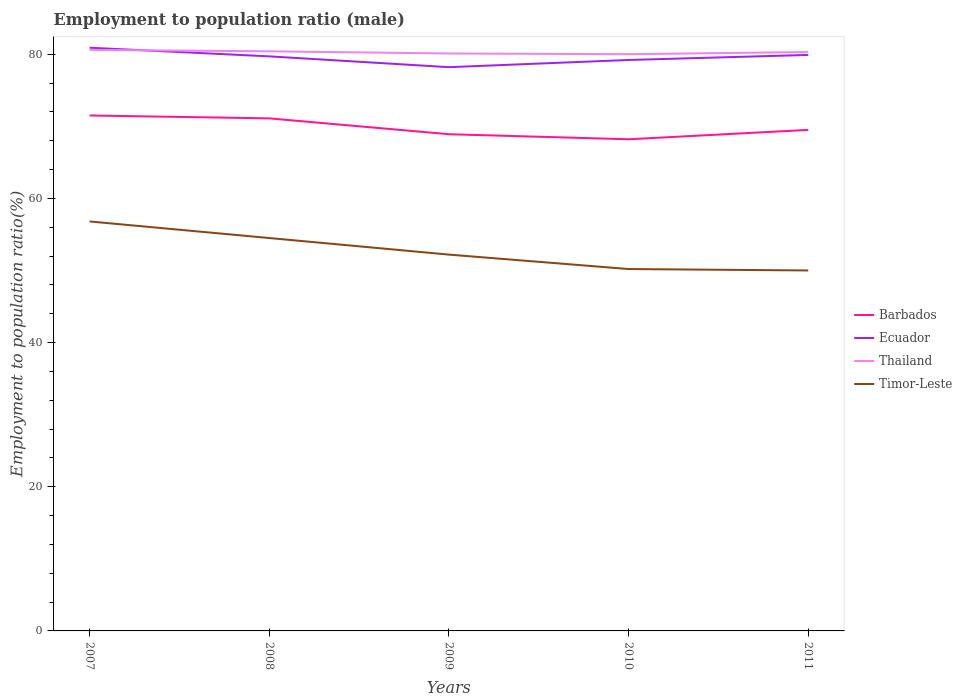Is the number of lines equal to the number of legend labels?
Offer a terse response. Yes. Across all years, what is the maximum employment to population ratio in Timor-Leste?
Keep it short and to the point. 50. In which year was the employment to population ratio in Thailand maximum?
Keep it short and to the point. 2010. What is the difference between the highest and the second highest employment to population ratio in Ecuador?
Ensure brevity in your answer.  2.7. Is the employment to population ratio in Barbados strictly greater than the employment to population ratio in Thailand over the years?
Ensure brevity in your answer.  Yes. How many lines are there?
Your answer should be compact. 4. How many years are there in the graph?
Your answer should be compact. 5. What is the difference between two consecutive major ticks on the Y-axis?
Offer a very short reply. 20. Does the graph contain any zero values?
Your response must be concise. No. How many legend labels are there?
Offer a terse response. 4. How are the legend labels stacked?
Your response must be concise. Vertical. What is the title of the graph?
Your answer should be very brief. Employment to population ratio (male). Does "Bulgaria" appear as one of the legend labels in the graph?
Ensure brevity in your answer.  No. What is the label or title of the X-axis?
Give a very brief answer. Years. What is the Employment to population ratio(%) in Barbados in 2007?
Offer a terse response. 71.5. What is the Employment to population ratio(%) of Ecuador in 2007?
Offer a very short reply. 80.9. What is the Employment to population ratio(%) of Thailand in 2007?
Ensure brevity in your answer.  80.6. What is the Employment to population ratio(%) in Timor-Leste in 2007?
Ensure brevity in your answer.  56.8. What is the Employment to population ratio(%) of Barbados in 2008?
Keep it short and to the point. 71.1. What is the Employment to population ratio(%) of Ecuador in 2008?
Your response must be concise. 79.7. What is the Employment to population ratio(%) in Thailand in 2008?
Provide a short and direct response. 80.4. What is the Employment to population ratio(%) of Timor-Leste in 2008?
Your answer should be compact. 54.5. What is the Employment to population ratio(%) in Barbados in 2009?
Provide a short and direct response. 68.9. What is the Employment to population ratio(%) in Ecuador in 2009?
Make the answer very short. 78.2. What is the Employment to population ratio(%) in Thailand in 2009?
Your response must be concise. 80.1. What is the Employment to population ratio(%) in Timor-Leste in 2009?
Keep it short and to the point. 52.2. What is the Employment to population ratio(%) in Barbados in 2010?
Offer a very short reply. 68.2. What is the Employment to population ratio(%) of Ecuador in 2010?
Offer a terse response. 79.2. What is the Employment to population ratio(%) of Thailand in 2010?
Your answer should be compact. 80. What is the Employment to population ratio(%) in Timor-Leste in 2010?
Offer a very short reply. 50.2. What is the Employment to population ratio(%) of Barbados in 2011?
Provide a succinct answer. 69.5. What is the Employment to population ratio(%) of Ecuador in 2011?
Keep it short and to the point. 79.9. What is the Employment to population ratio(%) of Thailand in 2011?
Make the answer very short. 80.3. What is the Employment to population ratio(%) in Timor-Leste in 2011?
Give a very brief answer. 50. Across all years, what is the maximum Employment to population ratio(%) in Barbados?
Give a very brief answer. 71.5. Across all years, what is the maximum Employment to population ratio(%) in Ecuador?
Provide a succinct answer. 80.9. Across all years, what is the maximum Employment to population ratio(%) of Thailand?
Your answer should be compact. 80.6. Across all years, what is the maximum Employment to population ratio(%) of Timor-Leste?
Offer a terse response. 56.8. Across all years, what is the minimum Employment to population ratio(%) in Barbados?
Make the answer very short. 68.2. Across all years, what is the minimum Employment to population ratio(%) of Ecuador?
Ensure brevity in your answer.  78.2. Across all years, what is the minimum Employment to population ratio(%) of Timor-Leste?
Ensure brevity in your answer.  50. What is the total Employment to population ratio(%) in Barbados in the graph?
Your answer should be very brief. 349.2. What is the total Employment to population ratio(%) of Ecuador in the graph?
Your answer should be compact. 397.9. What is the total Employment to population ratio(%) of Thailand in the graph?
Your answer should be compact. 401.4. What is the total Employment to population ratio(%) in Timor-Leste in the graph?
Give a very brief answer. 263.7. What is the difference between the Employment to population ratio(%) of Barbados in 2007 and that in 2008?
Your answer should be compact. 0.4. What is the difference between the Employment to population ratio(%) in Ecuador in 2007 and that in 2008?
Make the answer very short. 1.2. What is the difference between the Employment to population ratio(%) of Barbados in 2007 and that in 2009?
Give a very brief answer. 2.6. What is the difference between the Employment to population ratio(%) of Ecuador in 2007 and that in 2009?
Keep it short and to the point. 2.7. What is the difference between the Employment to population ratio(%) in Timor-Leste in 2007 and that in 2009?
Offer a terse response. 4.6. What is the difference between the Employment to population ratio(%) of Barbados in 2007 and that in 2010?
Offer a terse response. 3.3. What is the difference between the Employment to population ratio(%) in Ecuador in 2007 and that in 2010?
Offer a terse response. 1.7. What is the difference between the Employment to population ratio(%) in Thailand in 2007 and that in 2010?
Make the answer very short. 0.6. What is the difference between the Employment to population ratio(%) of Timor-Leste in 2007 and that in 2010?
Ensure brevity in your answer.  6.6. What is the difference between the Employment to population ratio(%) of Ecuador in 2007 and that in 2011?
Make the answer very short. 1. What is the difference between the Employment to population ratio(%) of Thailand in 2007 and that in 2011?
Your response must be concise. 0.3. What is the difference between the Employment to population ratio(%) in Ecuador in 2008 and that in 2009?
Your answer should be very brief. 1.5. What is the difference between the Employment to population ratio(%) of Timor-Leste in 2008 and that in 2009?
Your response must be concise. 2.3. What is the difference between the Employment to population ratio(%) of Barbados in 2008 and that in 2010?
Ensure brevity in your answer.  2.9. What is the difference between the Employment to population ratio(%) in Ecuador in 2008 and that in 2010?
Offer a terse response. 0.5. What is the difference between the Employment to population ratio(%) of Thailand in 2008 and that in 2010?
Give a very brief answer. 0.4. What is the difference between the Employment to population ratio(%) of Timor-Leste in 2008 and that in 2010?
Your response must be concise. 4.3. What is the difference between the Employment to population ratio(%) of Thailand in 2008 and that in 2011?
Keep it short and to the point. 0.1. What is the difference between the Employment to population ratio(%) in Barbados in 2009 and that in 2010?
Give a very brief answer. 0.7. What is the difference between the Employment to population ratio(%) in Barbados in 2009 and that in 2011?
Your answer should be compact. -0.6. What is the difference between the Employment to population ratio(%) of Ecuador in 2009 and that in 2011?
Ensure brevity in your answer.  -1.7. What is the difference between the Employment to population ratio(%) of Timor-Leste in 2009 and that in 2011?
Provide a succinct answer. 2.2. What is the difference between the Employment to population ratio(%) of Barbados in 2010 and that in 2011?
Your answer should be very brief. -1.3. What is the difference between the Employment to population ratio(%) in Timor-Leste in 2010 and that in 2011?
Your answer should be compact. 0.2. What is the difference between the Employment to population ratio(%) of Barbados in 2007 and the Employment to population ratio(%) of Ecuador in 2008?
Offer a very short reply. -8.2. What is the difference between the Employment to population ratio(%) in Barbados in 2007 and the Employment to population ratio(%) in Thailand in 2008?
Offer a very short reply. -8.9. What is the difference between the Employment to population ratio(%) of Barbados in 2007 and the Employment to population ratio(%) of Timor-Leste in 2008?
Ensure brevity in your answer.  17. What is the difference between the Employment to population ratio(%) in Ecuador in 2007 and the Employment to population ratio(%) in Thailand in 2008?
Provide a short and direct response. 0.5. What is the difference between the Employment to population ratio(%) of Ecuador in 2007 and the Employment to population ratio(%) of Timor-Leste in 2008?
Your answer should be very brief. 26.4. What is the difference between the Employment to population ratio(%) in Thailand in 2007 and the Employment to population ratio(%) in Timor-Leste in 2008?
Keep it short and to the point. 26.1. What is the difference between the Employment to population ratio(%) of Barbados in 2007 and the Employment to population ratio(%) of Ecuador in 2009?
Your answer should be very brief. -6.7. What is the difference between the Employment to population ratio(%) of Barbados in 2007 and the Employment to population ratio(%) of Timor-Leste in 2009?
Give a very brief answer. 19.3. What is the difference between the Employment to population ratio(%) of Ecuador in 2007 and the Employment to population ratio(%) of Thailand in 2009?
Provide a short and direct response. 0.8. What is the difference between the Employment to population ratio(%) in Ecuador in 2007 and the Employment to population ratio(%) in Timor-Leste in 2009?
Your response must be concise. 28.7. What is the difference between the Employment to population ratio(%) of Thailand in 2007 and the Employment to population ratio(%) of Timor-Leste in 2009?
Ensure brevity in your answer.  28.4. What is the difference between the Employment to population ratio(%) of Barbados in 2007 and the Employment to population ratio(%) of Ecuador in 2010?
Ensure brevity in your answer.  -7.7. What is the difference between the Employment to population ratio(%) of Barbados in 2007 and the Employment to population ratio(%) of Thailand in 2010?
Offer a terse response. -8.5. What is the difference between the Employment to population ratio(%) of Barbados in 2007 and the Employment to population ratio(%) of Timor-Leste in 2010?
Keep it short and to the point. 21.3. What is the difference between the Employment to population ratio(%) in Ecuador in 2007 and the Employment to population ratio(%) in Timor-Leste in 2010?
Your answer should be compact. 30.7. What is the difference between the Employment to population ratio(%) in Thailand in 2007 and the Employment to population ratio(%) in Timor-Leste in 2010?
Keep it short and to the point. 30.4. What is the difference between the Employment to population ratio(%) in Barbados in 2007 and the Employment to population ratio(%) in Ecuador in 2011?
Your response must be concise. -8.4. What is the difference between the Employment to population ratio(%) in Ecuador in 2007 and the Employment to population ratio(%) in Timor-Leste in 2011?
Ensure brevity in your answer.  30.9. What is the difference between the Employment to population ratio(%) in Thailand in 2007 and the Employment to population ratio(%) in Timor-Leste in 2011?
Ensure brevity in your answer.  30.6. What is the difference between the Employment to population ratio(%) in Barbados in 2008 and the Employment to population ratio(%) in Timor-Leste in 2009?
Your response must be concise. 18.9. What is the difference between the Employment to population ratio(%) in Ecuador in 2008 and the Employment to population ratio(%) in Thailand in 2009?
Make the answer very short. -0.4. What is the difference between the Employment to population ratio(%) in Thailand in 2008 and the Employment to population ratio(%) in Timor-Leste in 2009?
Make the answer very short. 28.2. What is the difference between the Employment to population ratio(%) of Barbados in 2008 and the Employment to population ratio(%) of Ecuador in 2010?
Keep it short and to the point. -8.1. What is the difference between the Employment to population ratio(%) of Barbados in 2008 and the Employment to population ratio(%) of Timor-Leste in 2010?
Make the answer very short. 20.9. What is the difference between the Employment to population ratio(%) of Ecuador in 2008 and the Employment to population ratio(%) of Timor-Leste in 2010?
Ensure brevity in your answer.  29.5. What is the difference between the Employment to population ratio(%) in Thailand in 2008 and the Employment to population ratio(%) in Timor-Leste in 2010?
Offer a very short reply. 30.2. What is the difference between the Employment to population ratio(%) of Barbados in 2008 and the Employment to population ratio(%) of Timor-Leste in 2011?
Give a very brief answer. 21.1. What is the difference between the Employment to population ratio(%) of Ecuador in 2008 and the Employment to population ratio(%) of Thailand in 2011?
Provide a short and direct response. -0.6. What is the difference between the Employment to population ratio(%) of Ecuador in 2008 and the Employment to population ratio(%) of Timor-Leste in 2011?
Your response must be concise. 29.7. What is the difference between the Employment to population ratio(%) in Thailand in 2008 and the Employment to population ratio(%) in Timor-Leste in 2011?
Offer a terse response. 30.4. What is the difference between the Employment to population ratio(%) of Barbados in 2009 and the Employment to population ratio(%) of Ecuador in 2010?
Your response must be concise. -10.3. What is the difference between the Employment to population ratio(%) in Barbados in 2009 and the Employment to population ratio(%) in Thailand in 2010?
Provide a succinct answer. -11.1. What is the difference between the Employment to population ratio(%) of Ecuador in 2009 and the Employment to population ratio(%) of Timor-Leste in 2010?
Provide a succinct answer. 28. What is the difference between the Employment to population ratio(%) of Thailand in 2009 and the Employment to population ratio(%) of Timor-Leste in 2010?
Offer a very short reply. 29.9. What is the difference between the Employment to population ratio(%) of Barbados in 2009 and the Employment to population ratio(%) of Thailand in 2011?
Your answer should be compact. -11.4. What is the difference between the Employment to population ratio(%) in Ecuador in 2009 and the Employment to population ratio(%) in Thailand in 2011?
Your answer should be compact. -2.1. What is the difference between the Employment to population ratio(%) of Ecuador in 2009 and the Employment to population ratio(%) of Timor-Leste in 2011?
Make the answer very short. 28.2. What is the difference between the Employment to population ratio(%) of Thailand in 2009 and the Employment to population ratio(%) of Timor-Leste in 2011?
Ensure brevity in your answer.  30.1. What is the difference between the Employment to population ratio(%) of Ecuador in 2010 and the Employment to population ratio(%) of Thailand in 2011?
Give a very brief answer. -1.1. What is the difference between the Employment to population ratio(%) of Ecuador in 2010 and the Employment to population ratio(%) of Timor-Leste in 2011?
Keep it short and to the point. 29.2. What is the difference between the Employment to population ratio(%) in Thailand in 2010 and the Employment to population ratio(%) in Timor-Leste in 2011?
Give a very brief answer. 30. What is the average Employment to population ratio(%) of Barbados per year?
Your response must be concise. 69.84. What is the average Employment to population ratio(%) in Ecuador per year?
Your answer should be very brief. 79.58. What is the average Employment to population ratio(%) in Thailand per year?
Make the answer very short. 80.28. What is the average Employment to population ratio(%) in Timor-Leste per year?
Provide a succinct answer. 52.74. In the year 2007, what is the difference between the Employment to population ratio(%) of Barbados and Employment to population ratio(%) of Timor-Leste?
Your answer should be very brief. 14.7. In the year 2007, what is the difference between the Employment to population ratio(%) in Ecuador and Employment to population ratio(%) in Thailand?
Make the answer very short. 0.3. In the year 2007, what is the difference between the Employment to population ratio(%) in Ecuador and Employment to population ratio(%) in Timor-Leste?
Give a very brief answer. 24.1. In the year 2007, what is the difference between the Employment to population ratio(%) of Thailand and Employment to population ratio(%) of Timor-Leste?
Your answer should be very brief. 23.8. In the year 2008, what is the difference between the Employment to population ratio(%) of Barbados and Employment to population ratio(%) of Thailand?
Your response must be concise. -9.3. In the year 2008, what is the difference between the Employment to population ratio(%) of Ecuador and Employment to population ratio(%) of Timor-Leste?
Your answer should be very brief. 25.2. In the year 2008, what is the difference between the Employment to population ratio(%) in Thailand and Employment to population ratio(%) in Timor-Leste?
Keep it short and to the point. 25.9. In the year 2009, what is the difference between the Employment to population ratio(%) of Barbados and Employment to population ratio(%) of Timor-Leste?
Your answer should be compact. 16.7. In the year 2009, what is the difference between the Employment to population ratio(%) of Ecuador and Employment to population ratio(%) of Timor-Leste?
Give a very brief answer. 26. In the year 2009, what is the difference between the Employment to population ratio(%) of Thailand and Employment to population ratio(%) of Timor-Leste?
Offer a terse response. 27.9. In the year 2010, what is the difference between the Employment to population ratio(%) of Barbados and Employment to population ratio(%) of Ecuador?
Provide a short and direct response. -11. In the year 2010, what is the difference between the Employment to population ratio(%) of Barbados and Employment to population ratio(%) of Timor-Leste?
Provide a succinct answer. 18. In the year 2010, what is the difference between the Employment to population ratio(%) in Ecuador and Employment to population ratio(%) in Thailand?
Ensure brevity in your answer.  -0.8. In the year 2010, what is the difference between the Employment to population ratio(%) in Thailand and Employment to population ratio(%) in Timor-Leste?
Offer a terse response. 29.8. In the year 2011, what is the difference between the Employment to population ratio(%) of Barbados and Employment to population ratio(%) of Thailand?
Ensure brevity in your answer.  -10.8. In the year 2011, what is the difference between the Employment to population ratio(%) in Barbados and Employment to population ratio(%) in Timor-Leste?
Your answer should be compact. 19.5. In the year 2011, what is the difference between the Employment to population ratio(%) in Ecuador and Employment to population ratio(%) in Timor-Leste?
Provide a short and direct response. 29.9. In the year 2011, what is the difference between the Employment to population ratio(%) of Thailand and Employment to population ratio(%) of Timor-Leste?
Ensure brevity in your answer.  30.3. What is the ratio of the Employment to population ratio(%) in Barbados in 2007 to that in 2008?
Keep it short and to the point. 1.01. What is the ratio of the Employment to population ratio(%) in Ecuador in 2007 to that in 2008?
Ensure brevity in your answer.  1.02. What is the ratio of the Employment to population ratio(%) of Timor-Leste in 2007 to that in 2008?
Offer a terse response. 1.04. What is the ratio of the Employment to population ratio(%) in Barbados in 2007 to that in 2009?
Your answer should be compact. 1.04. What is the ratio of the Employment to population ratio(%) of Ecuador in 2007 to that in 2009?
Your answer should be compact. 1.03. What is the ratio of the Employment to population ratio(%) of Thailand in 2007 to that in 2009?
Provide a short and direct response. 1.01. What is the ratio of the Employment to population ratio(%) in Timor-Leste in 2007 to that in 2009?
Provide a succinct answer. 1.09. What is the ratio of the Employment to population ratio(%) of Barbados in 2007 to that in 2010?
Your response must be concise. 1.05. What is the ratio of the Employment to population ratio(%) in Ecuador in 2007 to that in 2010?
Ensure brevity in your answer.  1.02. What is the ratio of the Employment to population ratio(%) in Thailand in 2007 to that in 2010?
Offer a terse response. 1.01. What is the ratio of the Employment to population ratio(%) in Timor-Leste in 2007 to that in 2010?
Provide a short and direct response. 1.13. What is the ratio of the Employment to population ratio(%) in Barbados in 2007 to that in 2011?
Make the answer very short. 1.03. What is the ratio of the Employment to population ratio(%) in Ecuador in 2007 to that in 2011?
Your answer should be compact. 1.01. What is the ratio of the Employment to population ratio(%) of Thailand in 2007 to that in 2011?
Offer a terse response. 1. What is the ratio of the Employment to population ratio(%) of Timor-Leste in 2007 to that in 2011?
Keep it short and to the point. 1.14. What is the ratio of the Employment to population ratio(%) in Barbados in 2008 to that in 2009?
Your response must be concise. 1.03. What is the ratio of the Employment to population ratio(%) of Ecuador in 2008 to that in 2009?
Make the answer very short. 1.02. What is the ratio of the Employment to population ratio(%) in Thailand in 2008 to that in 2009?
Keep it short and to the point. 1. What is the ratio of the Employment to population ratio(%) in Timor-Leste in 2008 to that in 2009?
Offer a terse response. 1.04. What is the ratio of the Employment to population ratio(%) of Barbados in 2008 to that in 2010?
Offer a terse response. 1.04. What is the ratio of the Employment to population ratio(%) in Ecuador in 2008 to that in 2010?
Your answer should be very brief. 1.01. What is the ratio of the Employment to population ratio(%) in Thailand in 2008 to that in 2010?
Make the answer very short. 1. What is the ratio of the Employment to population ratio(%) in Timor-Leste in 2008 to that in 2010?
Offer a terse response. 1.09. What is the ratio of the Employment to population ratio(%) in Timor-Leste in 2008 to that in 2011?
Make the answer very short. 1.09. What is the ratio of the Employment to population ratio(%) of Barbados in 2009 to that in 2010?
Keep it short and to the point. 1.01. What is the ratio of the Employment to population ratio(%) of Ecuador in 2009 to that in 2010?
Provide a succinct answer. 0.99. What is the ratio of the Employment to population ratio(%) in Timor-Leste in 2009 to that in 2010?
Offer a terse response. 1.04. What is the ratio of the Employment to population ratio(%) of Barbados in 2009 to that in 2011?
Give a very brief answer. 0.99. What is the ratio of the Employment to population ratio(%) of Ecuador in 2009 to that in 2011?
Provide a short and direct response. 0.98. What is the ratio of the Employment to population ratio(%) in Thailand in 2009 to that in 2011?
Keep it short and to the point. 1. What is the ratio of the Employment to population ratio(%) of Timor-Leste in 2009 to that in 2011?
Provide a short and direct response. 1.04. What is the ratio of the Employment to population ratio(%) of Barbados in 2010 to that in 2011?
Your response must be concise. 0.98. What is the ratio of the Employment to population ratio(%) of Thailand in 2010 to that in 2011?
Keep it short and to the point. 1. What is the difference between the highest and the second highest Employment to population ratio(%) of Barbados?
Make the answer very short. 0.4. What is the difference between the highest and the second highest Employment to population ratio(%) in Timor-Leste?
Your answer should be very brief. 2.3. What is the difference between the highest and the lowest Employment to population ratio(%) of Barbados?
Your answer should be compact. 3.3. What is the difference between the highest and the lowest Employment to population ratio(%) of Ecuador?
Offer a terse response. 2.7. What is the difference between the highest and the lowest Employment to population ratio(%) of Timor-Leste?
Provide a succinct answer. 6.8. 